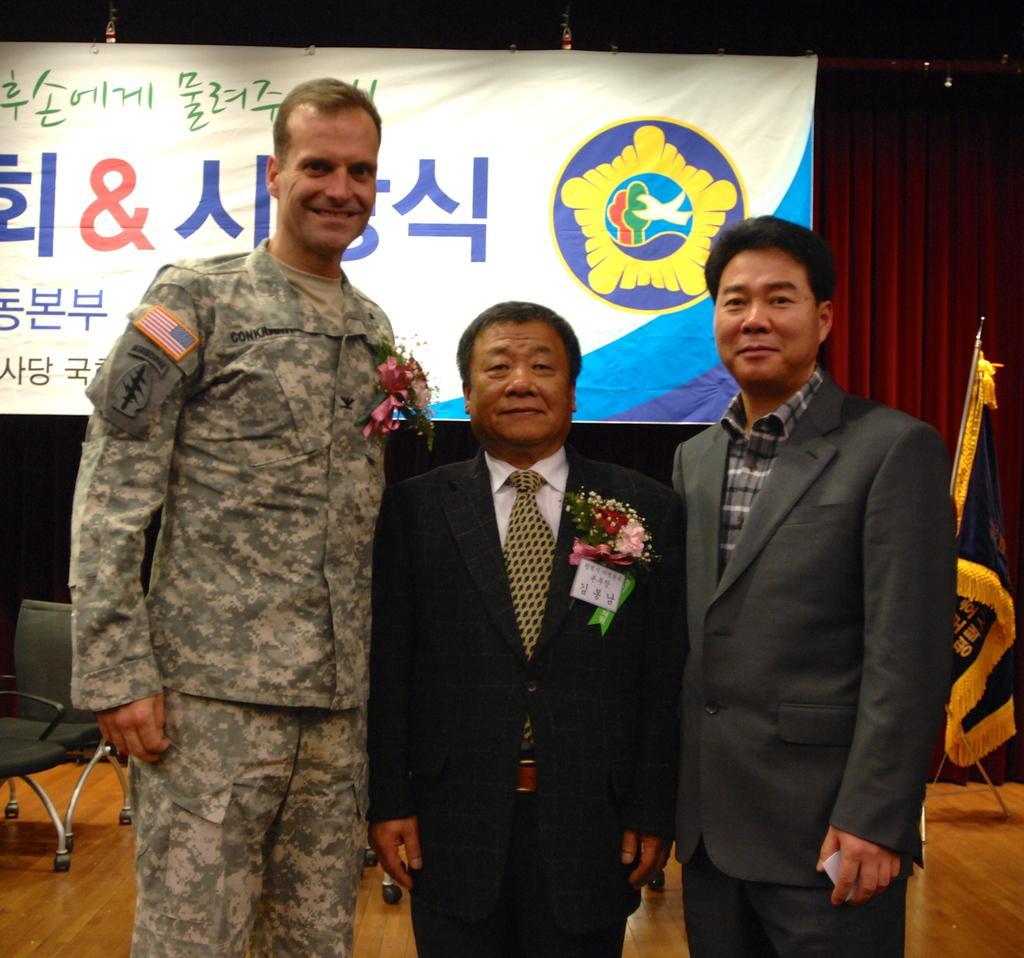In one or two sentences, can you explain what this image depicts? In this image, we can see some people standing and in the background there is a chair and there is a poster. 